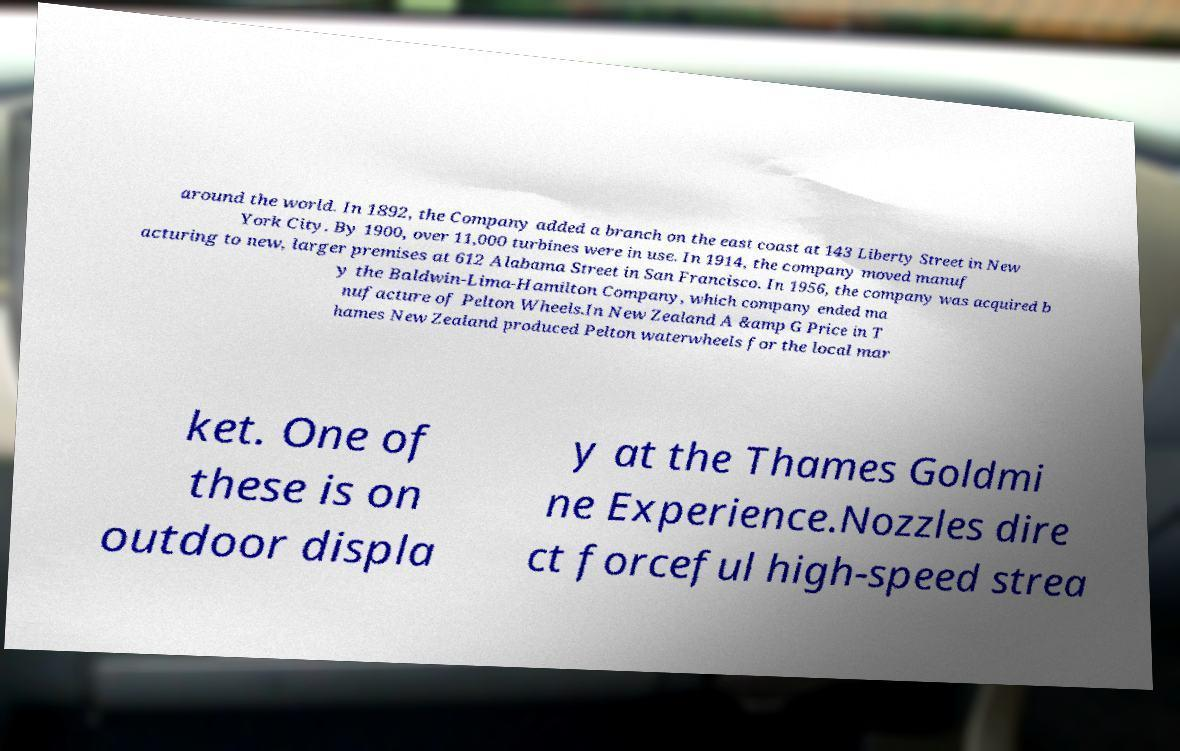Can you accurately transcribe the text from the provided image for me? around the world. In 1892, the Company added a branch on the east coast at 143 Liberty Street in New York City. By 1900, over 11,000 turbines were in use. In 1914, the company moved manuf acturing to new, larger premises at 612 Alabama Street in San Francisco. In 1956, the company was acquired b y the Baldwin-Lima-Hamilton Company, which company ended ma nufacture of Pelton Wheels.In New Zealand A &amp G Price in T hames New Zealand produced Pelton waterwheels for the local mar ket. One of these is on outdoor displa y at the Thames Goldmi ne Experience.Nozzles dire ct forceful high-speed strea 